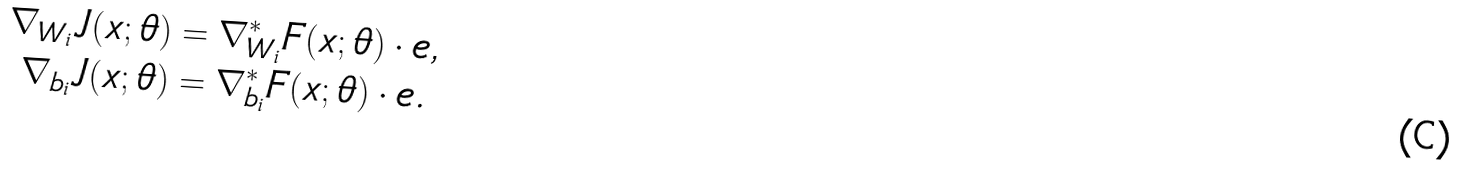<formula> <loc_0><loc_0><loc_500><loc_500>\nabla _ { W _ { i } } J ( x ; \theta ) & = \nabla ^ { * } _ { W _ { i } } F ( x ; \theta ) \cdot e , \\ \nabla _ { b _ { i } } J ( x ; \theta ) & = \nabla ^ { * } _ { b _ { i } } F ( x ; \theta ) \cdot e .</formula> 